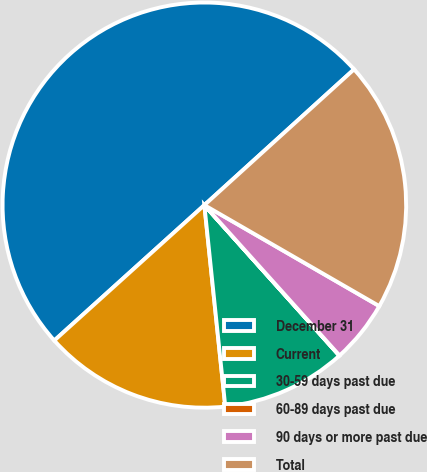Convert chart. <chart><loc_0><loc_0><loc_500><loc_500><pie_chart><fcel>December 31<fcel>Current<fcel>30-59 days past due<fcel>60-89 days past due<fcel>90 days or more past due<fcel>Total<nl><fcel>49.96%<fcel>15.0%<fcel>10.01%<fcel>0.02%<fcel>5.01%<fcel>20.0%<nl></chart> 